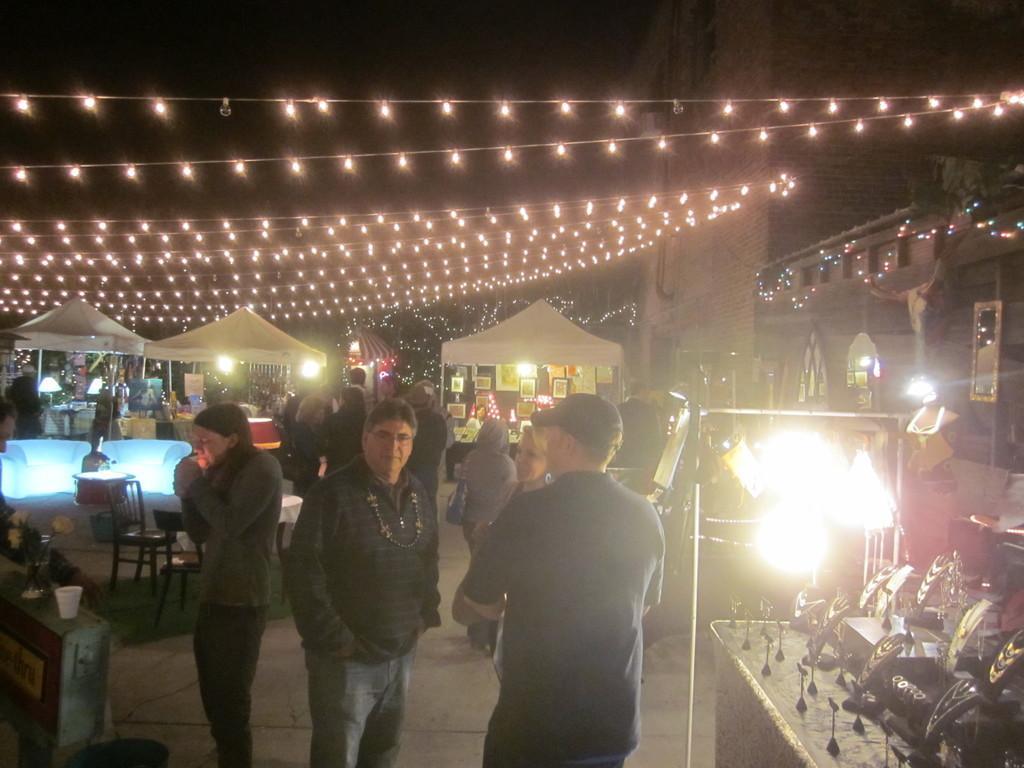How would you summarize this image in a sentence or two? In this image we can see some people standing on the road. We can also see a table with a flower pot and a glass, a dustbin, table with chairs, a lamp, tents, lighting, building, photo frames, mirror and a stand. On the right side we can see some jewelry placed on the table. 